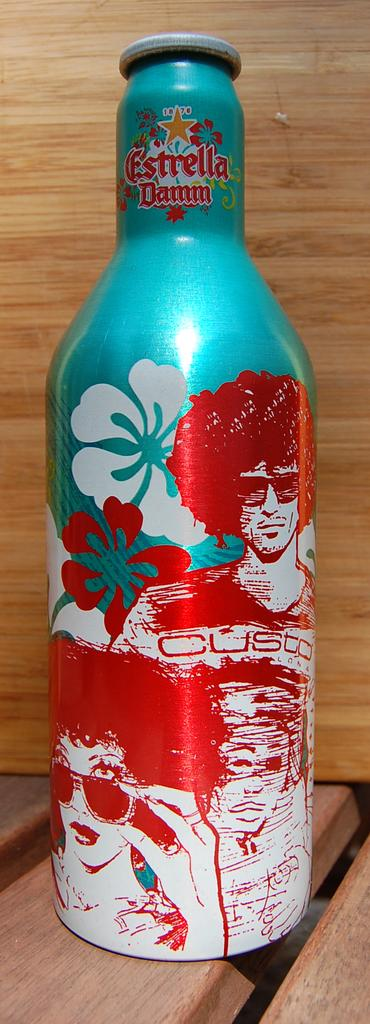<image>
Relay a brief, clear account of the picture shown. an aluminum bottle of estrella damm that is red white and blue 